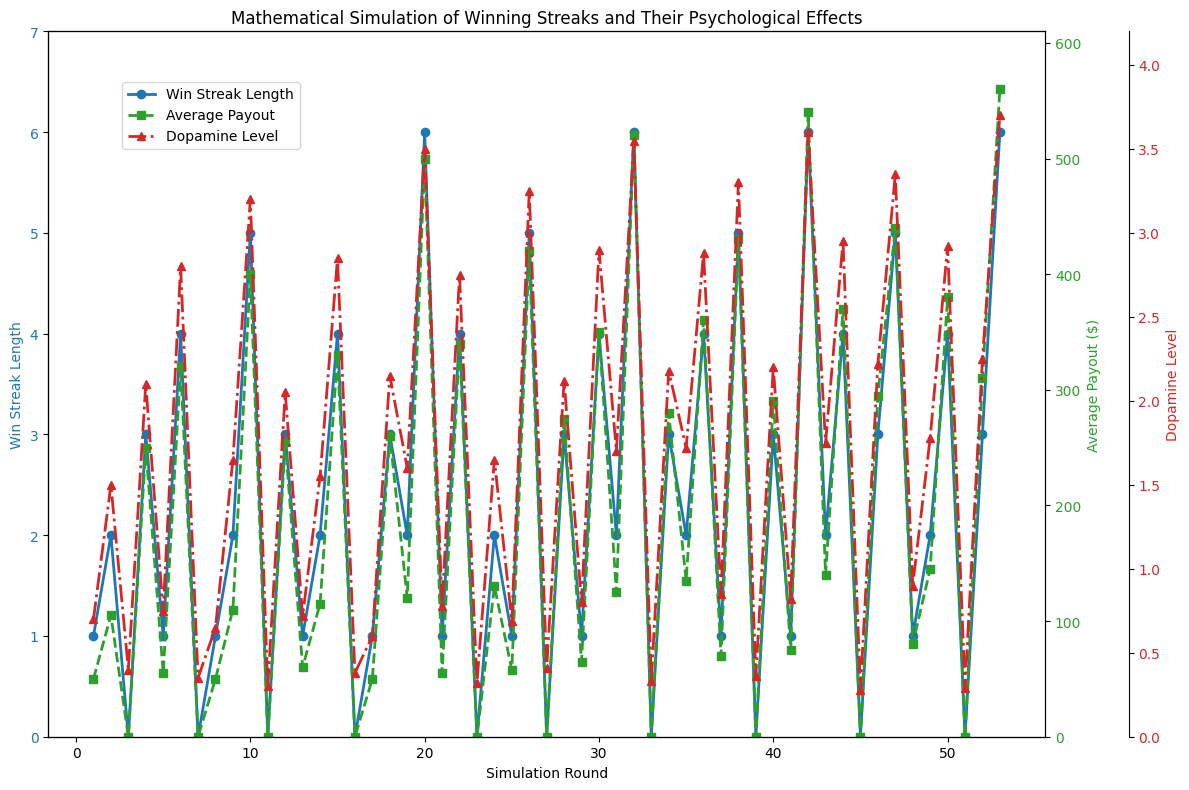What's the maximum Win Streak Length observed in the simulation? The maximum Win Streak Length can be identified by looking at the highest point on the Win Streak Length plot (blue line).
Answer: 6 During which simulation round was the highest Dopamine Level recorded? The highest Dopamine Level can be found by identifying the highest point on the Dopamine Level plot (red line) and then checking the corresponding simulation round on the x-axis.
Answer: 42 What is the difference in Dopamine Level between simulation rounds 10 and 20? First, identify the Dopamine Levels at rounds 10 and 20 from the red line plot. The values are 3.20 at round 10 and 3.50 at round 20. The difference is calculated as 3.50 - 3.20.
Answer: 0.30 How does the Average Payout at simulation round 26 compare to that at simulation round 30? Identify the Average Payout values at rounds 26 and 30 from the green line plot. The values are 420 and 350 respectively. Compare the two values. 420 is greater than 350.
Answer: Greater What's the average Dopamine Level across all simulation rounds? Sum all Dopamine Level values from each round and divide by the total number of rounds (53). Calculation involves summing all Dopamine Levels and then dividing by 53. (Sum = 89.55, 89.55 / 53 ≈ 1.69)
Answer: 1.69 When the Average Payout was highest, what was the Win Streak Length and Dopamine Level? The highest Average Payout is marked by the highest point on the green line plot. Identify the simulation round corresponding to this point, then note the Win Streak Length and Dopamine Level values for that round. At round 53, the Average Payout is 560, Win Streak Length is 6, and Dopamine Level is 3.70.
Answer: 6, 3.70 Which simulation rounds have an Average Payout of zero? Check the green line plot for points where the Average Payout is zero and note the corresponding simulation rounds. These points occur at rounds 3, 7, 11, 16, 23, 27, 33, 39, 45, and 51.
Answer: 3, 7, 11, 16, 23, 27, 33, 39, 45, 51 Is there a general correlation between Win Streak Length and Average Payout? Observe the blue and green lines. Generally, when Win Streak Length increases, the Average Payout also tends to increase, indicating a positive correlation.
Answer: Yes What's the combined Win Streak Length for simulation rounds where the Dopamine Level is above 3.0? Identify rounds with Dopamine Level > 3.0 from the red line plot: rounds 10, 20, 26, 32, 38, 42, and 53, and sum their Win Streak Length values: (5+6+5+6+5+6+6)=39
Answer: 39 What is the trend of the Dopamine Level when the Average Payout is increasing? Cross-reference the green line plot with the red line plot. When the Average Payout increases, the Dopamine Level also tends to increase, indicating a positive trend.
Answer: Increase 